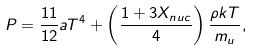<formula> <loc_0><loc_0><loc_500><loc_500>P = \frac { 1 1 } { 1 2 } a T ^ { 4 } + \left ( \frac { 1 + 3 X _ { n u c } } { 4 } \right ) \frac { \rho k T } { m _ { u } } ,</formula> 